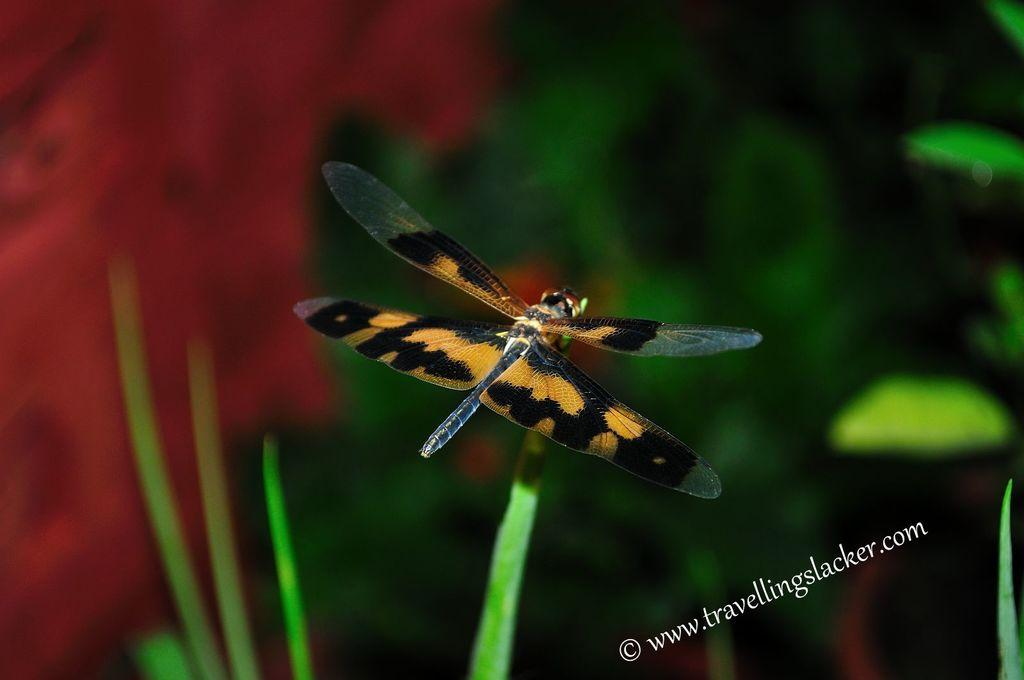What insect is present in the image? There is a dragonfly in the image. What is the dragonfly resting on? The dragonfly is laying on grass. How would you describe the background of the image? The background of the dragonfly is blurred. What type of pollution can be seen in the image? There is no pollution present in the image; it features a dragonfly laying on grass with a blurred background. Can you tell me how many seats are visible in the image? There are no seats present in the image. 